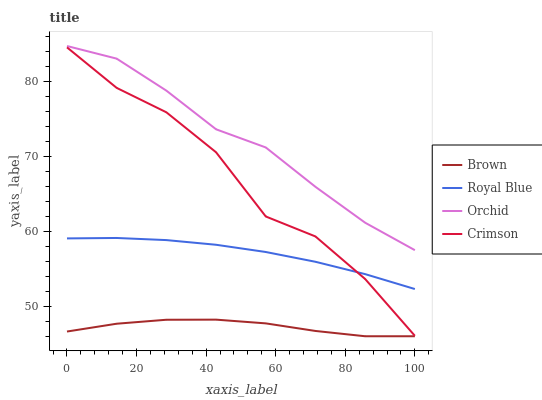Does Orchid have the minimum area under the curve?
Answer yes or no. No. Does Brown have the maximum area under the curve?
Answer yes or no. No. Is Brown the smoothest?
Answer yes or no. No. Is Brown the roughest?
Answer yes or no. No. Does Orchid have the lowest value?
Answer yes or no. No. Does Brown have the highest value?
Answer yes or no. No. Is Royal Blue less than Orchid?
Answer yes or no. Yes. Is Orchid greater than Crimson?
Answer yes or no. Yes. Does Royal Blue intersect Orchid?
Answer yes or no. No. 